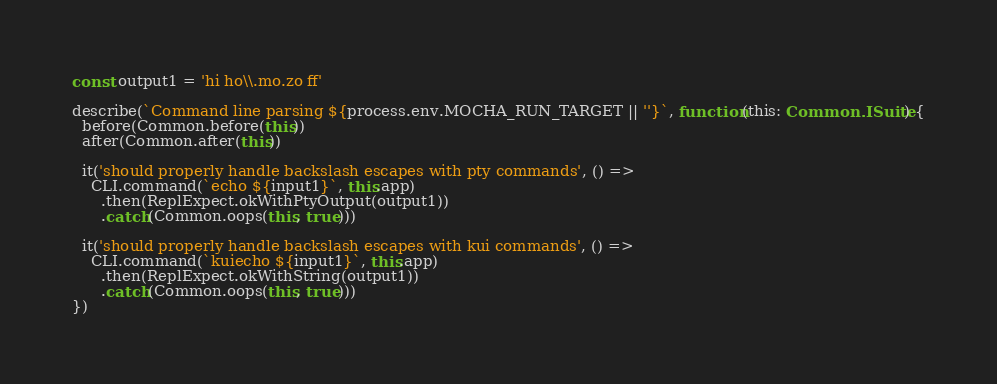Convert code to text. <code><loc_0><loc_0><loc_500><loc_500><_TypeScript_>const output1 = 'hi ho\\.mo.zo ff'

describe(`Command line parsing ${process.env.MOCHA_RUN_TARGET || ''}`, function(this: Common.ISuite) {
  before(Common.before(this))
  after(Common.after(this))

  it('should properly handle backslash escapes with pty commands', () =>
    CLI.command(`echo ${input1}`, this.app)
      .then(ReplExpect.okWithPtyOutput(output1))
      .catch(Common.oops(this, true)))

  it('should properly handle backslash escapes with kui commands', () =>
    CLI.command(`kuiecho ${input1}`, this.app)
      .then(ReplExpect.okWithString(output1))
      .catch(Common.oops(this, true)))
})
</code> 